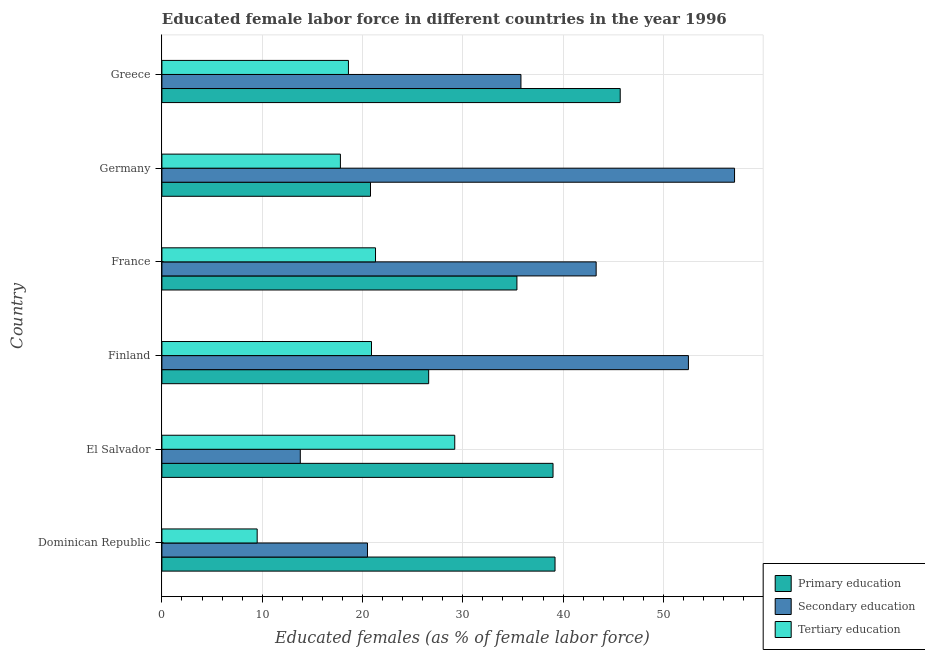How many different coloured bars are there?
Your response must be concise. 3. How many groups of bars are there?
Make the answer very short. 6. Are the number of bars per tick equal to the number of legend labels?
Make the answer very short. Yes. In how many cases, is the number of bars for a given country not equal to the number of legend labels?
Offer a very short reply. 0. What is the percentage of female labor force who received primary education in Germany?
Provide a succinct answer. 20.8. Across all countries, what is the maximum percentage of female labor force who received tertiary education?
Provide a short and direct response. 29.2. Across all countries, what is the minimum percentage of female labor force who received tertiary education?
Give a very brief answer. 9.5. In which country was the percentage of female labor force who received tertiary education maximum?
Your answer should be very brief. El Salvador. In which country was the percentage of female labor force who received secondary education minimum?
Make the answer very short. El Salvador. What is the total percentage of female labor force who received tertiary education in the graph?
Offer a very short reply. 117.3. What is the difference between the percentage of female labor force who received primary education in Greece and the percentage of female labor force who received tertiary education in France?
Keep it short and to the point. 24.4. What is the average percentage of female labor force who received secondary education per country?
Your answer should be very brief. 37.17. What is the difference between the percentage of female labor force who received primary education and percentage of female labor force who received tertiary education in Greece?
Provide a succinct answer. 27.1. In how many countries, is the percentage of female labor force who received tertiary education greater than 42 %?
Make the answer very short. 0. What is the ratio of the percentage of female labor force who received secondary education in Finland to that in Greece?
Provide a succinct answer. 1.47. Is the difference between the percentage of female labor force who received secondary education in Finland and Greece greater than the difference between the percentage of female labor force who received primary education in Finland and Greece?
Give a very brief answer. Yes. What is the difference between the highest and the second highest percentage of female labor force who received tertiary education?
Keep it short and to the point. 7.9. What is the difference between the highest and the lowest percentage of female labor force who received secondary education?
Make the answer very short. 43.3. What does the 1st bar from the top in Dominican Republic represents?
Give a very brief answer. Tertiary education. What does the 3rd bar from the bottom in Germany represents?
Make the answer very short. Tertiary education. Are the values on the major ticks of X-axis written in scientific E-notation?
Give a very brief answer. No. Does the graph contain grids?
Your response must be concise. Yes. How many legend labels are there?
Make the answer very short. 3. How are the legend labels stacked?
Ensure brevity in your answer.  Vertical. What is the title of the graph?
Give a very brief answer. Educated female labor force in different countries in the year 1996. Does "Spain" appear as one of the legend labels in the graph?
Provide a succinct answer. No. What is the label or title of the X-axis?
Make the answer very short. Educated females (as % of female labor force). What is the label or title of the Y-axis?
Offer a very short reply. Country. What is the Educated females (as % of female labor force) in Primary education in Dominican Republic?
Your answer should be compact. 39.2. What is the Educated females (as % of female labor force) in Primary education in El Salvador?
Provide a short and direct response. 39. What is the Educated females (as % of female labor force) of Secondary education in El Salvador?
Keep it short and to the point. 13.8. What is the Educated females (as % of female labor force) of Tertiary education in El Salvador?
Provide a succinct answer. 29.2. What is the Educated females (as % of female labor force) in Primary education in Finland?
Keep it short and to the point. 26.6. What is the Educated females (as % of female labor force) in Secondary education in Finland?
Offer a very short reply. 52.5. What is the Educated females (as % of female labor force) of Tertiary education in Finland?
Provide a short and direct response. 20.9. What is the Educated females (as % of female labor force) in Primary education in France?
Your answer should be very brief. 35.4. What is the Educated females (as % of female labor force) of Secondary education in France?
Provide a short and direct response. 43.3. What is the Educated females (as % of female labor force) in Tertiary education in France?
Keep it short and to the point. 21.3. What is the Educated females (as % of female labor force) in Primary education in Germany?
Ensure brevity in your answer.  20.8. What is the Educated females (as % of female labor force) in Secondary education in Germany?
Offer a very short reply. 57.1. What is the Educated females (as % of female labor force) in Tertiary education in Germany?
Your answer should be compact. 17.8. What is the Educated females (as % of female labor force) of Primary education in Greece?
Keep it short and to the point. 45.7. What is the Educated females (as % of female labor force) in Secondary education in Greece?
Ensure brevity in your answer.  35.8. What is the Educated females (as % of female labor force) in Tertiary education in Greece?
Your response must be concise. 18.6. Across all countries, what is the maximum Educated females (as % of female labor force) in Primary education?
Your answer should be very brief. 45.7. Across all countries, what is the maximum Educated females (as % of female labor force) in Secondary education?
Give a very brief answer. 57.1. Across all countries, what is the maximum Educated females (as % of female labor force) of Tertiary education?
Offer a very short reply. 29.2. Across all countries, what is the minimum Educated females (as % of female labor force) of Primary education?
Give a very brief answer. 20.8. Across all countries, what is the minimum Educated females (as % of female labor force) in Secondary education?
Offer a very short reply. 13.8. Across all countries, what is the minimum Educated females (as % of female labor force) of Tertiary education?
Offer a terse response. 9.5. What is the total Educated females (as % of female labor force) in Primary education in the graph?
Your answer should be very brief. 206.7. What is the total Educated females (as % of female labor force) in Secondary education in the graph?
Your response must be concise. 223. What is the total Educated females (as % of female labor force) of Tertiary education in the graph?
Your answer should be very brief. 117.3. What is the difference between the Educated females (as % of female labor force) of Primary education in Dominican Republic and that in El Salvador?
Ensure brevity in your answer.  0.2. What is the difference between the Educated females (as % of female labor force) of Tertiary education in Dominican Republic and that in El Salvador?
Provide a succinct answer. -19.7. What is the difference between the Educated females (as % of female labor force) of Secondary education in Dominican Republic and that in Finland?
Give a very brief answer. -32. What is the difference between the Educated females (as % of female labor force) of Tertiary education in Dominican Republic and that in Finland?
Your answer should be compact. -11.4. What is the difference between the Educated females (as % of female labor force) in Secondary education in Dominican Republic and that in France?
Give a very brief answer. -22.8. What is the difference between the Educated females (as % of female labor force) in Tertiary education in Dominican Republic and that in France?
Offer a very short reply. -11.8. What is the difference between the Educated females (as % of female labor force) in Primary education in Dominican Republic and that in Germany?
Offer a terse response. 18.4. What is the difference between the Educated females (as % of female labor force) in Secondary education in Dominican Republic and that in Germany?
Your answer should be very brief. -36.6. What is the difference between the Educated females (as % of female labor force) in Secondary education in Dominican Republic and that in Greece?
Offer a very short reply. -15.3. What is the difference between the Educated females (as % of female labor force) of Secondary education in El Salvador and that in Finland?
Your response must be concise. -38.7. What is the difference between the Educated females (as % of female labor force) in Tertiary education in El Salvador and that in Finland?
Your answer should be compact. 8.3. What is the difference between the Educated females (as % of female labor force) of Secondary education in El Salvador and that in France?
Keep it short and to the point. -29.5. What is the difference between the Educated females (as % of female labor force) of Tertiary education in El Salvador and that in France?
Provide a short and direct response. 7.9. What is the difference between the Educated females (as % of female labor force) in Primary education in El Salvador and that in Germany?
Your answer should be compact. 18.2. What is the difference between the Educated females (as % of female labor force) in Secondary education in El Salvador and that in Germany?
Give a very brief answer. -43.3. What is the difference between the Educated females (as % of female labor force) in Primary education in El Salvador and that in Greece?
Offer a terse response. -6.7. What is the difference between the Educated females (as % of female labor force) in Secondary education in El Salvador and that in Greece?
Offer a terse response. -22. What is the difference between the Educated females (as % of female labor force) of Primary education in Finland and that in France?
Your answer should be compact. -8.8. What is the difference between the Educated females (as % of female labor force) in Secondary education in Finland and that in France?
Give a very brief answer. 9.2. What is the difference between the Educated females (as % of female labor force) in Tertiary education in Finland and that in France?
Your answer should be very brief. -0.4. What is the difference between the Educated females (as % of female labor force) in Tertiary education in Finland and that in Germany?
Offer a terse response. 3.1. What is the difference between the Educated females (as % of female labor force) in Primary education in Finland and that in Greece?
Provide a succinct answer. -19.1. What is the difference between the Educated females (as % of female labor force) in Tertiary education in Finland and that in Greece?
Keep it short and to the point. 2.3. What is the difference between the Educated females (as % of female labor force) of Secondary education in France and that in Germany?
Keep it short and to the point. -13.8. What is the difference between the Educated females (as % of female labor force) of Tertiary education in France and that in Germany?
Offer a terse response. 3.5. What is the difference between the Educated females (as % of female labor force) of Primary education in France and that in Greece?
Keep it short and to the point. -10.3. What is the difference between the Educated females (as % of female labor force) of Tertiary education in France and that in Greece?
Provide a succinct answer. 2.7. What is the difference between the Educated females (as % of female labor force) of Primary education in Germany and that in Greece?
Your answer should be compact. -24.9. What is the difference between the Educated females (as % of female labor force) in Secondary education in Germany and that in Greece?
Provide a short and direct response. 21.3. What is the difference between the Educated females (as % of female labor force) of Tertiary education in Germany and that in Greece?
Offer a terse response. -0.8. What is the difference between the Educated females (as % of female labor force) of Primary education in Dominican Republic and the Educated females (as % of female labor force) of Secondary education in El Salvador?
Ensure brevity in your answer.  25.4. What is the difference between the Educated females (as % of female labor force) in Primary education in Dominican Republic and the Educated females (as % of female labor force) in Secondary education in Finland?
Offer a terse response. -13.3. What is the difference between the Educated females (as % of female labor force) in Primary education in Dominican Republic and the Educated females (as % of female labor force) in Tertiary education in Finland?
Your response must be concise. 18.3. What is the difference between the Educated females (as % of female labor force) of Primary education in Dominican Republic and the Educated females (as % of female labor force) of Secondary education in Germany?
Offer a terse response. -17.9. What is the difference between the Educated females (as % of female labor force) of Primary education in Dominican Republic and the Educated females (as % of female labor force) of Tertiary education in Germany?
Your answer should be compact. 21.4. What is the difference between the Educated females (as % of female labor force) in Primary education in Dominican Republic and the Educated females (as % of female labor force) in Tertiary education in Greece?
Give a very brief answer. 20.6. What is the difference between the Educated females (as % of female labor force) in Secondary education in Dominican Republic and the Educated females (as % of female labor force) in Tertiary education in Greece?
Keep it short and to the point. 1.9. What is the difference between the Educated females (as % of female labor force) of Primary education in El Salvador and the Educated females (as % of female labor force) of Secondary education in Finland?
Your answer should be compact. -13.5. What is the difference between the Educated females (as % of female labor force) in Primary education in El Salvador and the Educated females (as % of female labor force) in Tertiary education in Finland?
Provide a succinct answer. 18.1. What is the difference between the Educated females (as % of female labor force) of Primary education in El Salvador and the Educated females (as % of female labor force) of Secondary education in France?
Offer a terse response. -4.3. What is the difference between the Educated females (as % of female labor force) of Primary education in El Salvador and the Educated females (as % of female labor force) of Tertiary education in France?
Ensure brevity in your answer.  17.7. What is the difference between the Educated females (as % of female labor force) of Secondary education in El Salvador and the Educated females (as % of female labor force) of Tertiary education in France?
Keep it short and to the point. -7.5. What is the difference between the Educated females (as % of female labor force) in Primary education in El Salvador and the Educated females (as % of female labor force) in Secondary education in Germany?
Your answer should be very brief. -18.1. What is the difference between the Educated females (as % of female labor force) of Primary education in El Salvador and the Educated females (as % of female labor force) of Tertiary education in Germany?
Make the answer very short. 21.2. What is the difference between the Educated females (as % of female labor force) of Primary education in El Salvador and the Educated females (as % of female labor force) of Tertiary education in Greece?
Your answer should be very brief. 20.4. What is the difference between the Educated females (as % of female labor force) of Primary education in Finland and the Educated females (as % of female labor force) of Secondary education in France?
Offer a very short reply. -16.7. What is the difference between the Educated females (as % of female labor force) of Secondary education in Finland and the Educated females (as % of female labor force) of Tertiary education in France?
Ensure brevity in your answer.  31.2. What is the difference between the Educated females (as % of female labor force) of Primary education in Finland and the Educated females (as % of female labor force) of Secondary education in Germany?
Your answer should be compact. -30.5. What is the difference between the Educated females (as % of female labor force) in Primary education in Finland and the Educated females (as % of female labor force) in Tertiary education in Germany?
Provide a succinct answer. 8.8. What is the difference between the Educated females (as % of female labor force) in Secondary education in Finland and the Educated females (as % of female labor force) in Tertiary education in Germany?
Your answer should be very brief. 34.7. What is the difference between the Educated females (as % of female labor force) in Primary education in Finland and the Educated females (as % of female labor force) in Tertiary education in Greece?
Offer a very short reply. 8. What is the difference between the Educated females (as % of female labor force) of Secondary education in Finland and the Educated females (as % of female labor force) of Tertiary education in Greece?
Provide a succinct answer. 33.9. What is the difference between the Educated females (as % of female labor force) in Primary education in France and the Educated females (as % of female labor force) in Secondary education in Germany?
Keep it short and to the point. -21.7. What is the difference between the Educated females (as % of female labor force) of Primary education in France and the Educated females (as % of female labor force) of Tertiary education in Greece?
Provide a short and direct response. 16.8. What is the difference between the Educated females (as % of female labor force) of Secondary education in France and the Educated females (as % of female labor force) of Tertiary education in Greece?
Provide a short and direct response. 24.7. What is the difference between the Educated females (as % of female labor force) of Primary education in Germany and the Educated females (as % of female labor force) of Secondary education in Greece?
Give a very brief answer. -15. What is the difference between the Educated females (as % of female labor force) in Secondary education in Germany and the Educated females (as % of female labor force) in Tertiary education in Greece?
Make the answer very short. 38.5. What is the average Educated females (as % of female labor force) of Primary education per country?
Offer a very short reply. 34.45. What is the average Educated females (as % of female labor force) of Secondary education per country?
Your response must be concise. 37.17. What is the average Educated females (as % of female labor force) of Tertiary education per country?
Make the answer very short. 19.55. What is the difference between the Educated females (as % of female labor force) in Primary education and Educated females (as % of female labor force) in Secondary education in Dominican Republic?
Your answer should be very brief. 18.7. What is the difference between the Educated females (as % of female labor force) in Primary education and Educated females (as % of female labor force) in Tertiary education in Dominican Republic?
Ensure brevity in your answer.  29.7. What is the difference between the Educated females (as % of female labor force) in Primary education and Educated females (as % of female labor force) in Secondary education in El Salvador?
Give a very brief answer. 25.2. What is the difference between the Educated females (as % of female labor force) in Secondary education and Educated females (as % of female labor force) in Tertiary education in El Salvador?
Provide a short and direct response. -15.4. What is the difference between the Educated females (as % of female labor force) in Primary education and Educated females (as % of female labor force) in Secondary education in Finland?
Make the answer very short. -25.9. What is the difference between the Educated females (as % of female labor force) of Secondary education and Educated females (as % of female labor force) of Tertiary education in Finland?
Provide a short and direct response. 31.6. What is the difference between the Educated females (as % of female labor force) in Primary education and Educated females (as % of female labor force) in Tertiary education in France?
Your response must be concise. 14.1. What is the difference between the Educated females (as % of female labor force) in Primary education and Educated females (as % of female labor force) in Secondary education in Germany?
Make the answer very short. -36.3. What is the difference between the Educated females (as % of female labor force) of Secondary education and Educated females (as % of female labor force) of Tertiary education in Germany?
Your answer should be compact. 39.3. What is the difference between the Educated females (as % of female labor force) of Primary education and Educated females (as % of female labor force) of Tertiary education in Greece?
Your answer should be compact. 27.1. What is the ratio of the Educated females (as % of female labor force) of Primary education in Dominican Republic to that in El Salvador?
Keep it short and to the point. 1.01. What is the ratio of the Educated females (as % of female labor force) in Secondary education in Dominican Republic to that in El Salvador?
Offer a terse response. 1.49. What is the ratio of the Educated females (as % of female labor force) in Tertiary education in Dominican Republic to that in El Salvador?
Give a very brief answer. 0.33. What is the ratio of the Educated females (as % of female labor force) in Primary education in Dominican Republic to that in Finland?
Give a very brief answer. 1.47. What is the ratio of the Educated females (as % of female labor force) of Secondary education in Dominican Republic to that in Finland?
Keep it short and to the point. 0.39. What is the ratio of the Educated females (as % of female labor force) in Tertiary education in Dominican Republic to that in Finland?
Your answer should be very brief. 0.45. What is the ratio of the Educated females (as % of female labor force) of Primary education in Dominican Republic to that in France?
Make the answer very short. 1.11. What is the ratio of the Educated females (as % of female labor force) in Secondary education in Dominican Republic to that in France?
Offer a very short reply. 0.47. What is the ratio of the Educated females (as % of female labor force) in Tertiary education in Dominican Republic to that in France?
Keep it short and to the point. 0.45. What is the ratio of the Educated females (as % of female labor force) in Primary education in Dominican Republic to that in Germany?
Give a very brief answer. 1.88. What is the ratio of the Educated females (as % of female labor force) of Secondary education in Dominican Republic to that in Germany?
Provide a short and direct response. 0.36. What is the ratio of the Educated females (as % of female labor force) of Tertiary education in Dominican Republic to that in Germany?
Provide a succinct answer. 0.53. What is the ratio of the Educated females (as % of female labor force) in Primary education in Dominican Republic to that in Greece?
Ensure brevity in your answer.  0.86. What is the ratio of the Educated females (as % of female labor force) in Secondary education in Dominican Republic to that in Greece?
Offer a very short reply. 0.57. What is the ratio of the Educated females (as % of female labor force) of Tertiary education in Dominican Republic to that in Greece?
Provide a short and direct response. 0.51. What is the ratio of the Educated females (as % of female labor force) in Primary education in El Salvador to that in Finland?
Keep it short and to the point. 1.47. What is the ratio of the Educated females (as % of female labor force) in Secondary education in El Salvador to that in Finland?
Ensure brevity in your answer.  0.26. What is the ratio of the Educated females (as % of female labor force) in Tertiary education in El Salvador to that in Finland?
Offer a terse response. 1.4. What is the ratio of the Educated females (as % of female labor force) of Primary education in El Salvador to that in France?
Your response must be concise. 1.1. What is the ratio of the Educated females (as % of female labor force) in Secondary education in El Salvador to that in France?
Your answer should be very brief. 0.32. What is the ratio of the Educated females (as % of female labor force) in Tertiary education in El Salvador to that in France?
Your answer should be compact. 1.37. What is the ratio of the Educated females (as % of female labor force) of Primary education in El Salvador to that in Germany?
Offer a terse response. 1.88. What is the ratio of the Educated females (as % of female labor force) in Secondary education in El Salvador to that in Germany?
Offer a terse response. 0.24. What is the ratio of the Educated females (as % of female labor force) of Tertiary education in El Salvador to that in Germany?
Your answer should be compact. 1.64. What is the ratio of the Educated females (as % of female labor force) in Primary education in El Salvador to that in Greece?
Make the answer very short. 0.85. What is the ratio of the Educated females (as % of female labor force) of Secondary education in El Salvador to that in Greece?
Provide a short and direct response. 0.39. What is the ratio of the Educated females (as % of female labor force) of Tertiary education in El Salvador to that in Greece?
Ensure brevity in your answer.  1.57. What is the ratio of the Educated females (as % of female labor force) in Primary education in Finland to that in France?
Offer a terse response. 0.75. What is the ratio of the Educated females (as % of female labor force) of Secondary education in Finland to that in France?
Your answer should be compact. 1.21. What is the ratio of the Educated females (as % of female labor force) of Tertiary education in Finland to that in France?
Offer a very short reply. 0.98. What is the ratio of the Educated females (as % of female labor force) of Primary education in Finland to that in Germany?
Your response must be concise. 1.28. What is the ratio of the Educated females (as % of female labor force) in Secondary education in Finland to that in Germany?
Ensure brevity in your answer.  0.92. What is the ratio of the Educated females (as % of female labor force) of Tertiary education in Finland to that in Germany?
Your answer should be compact. 1.17. What is the ratio of the Educated females (as % of female labor force) of Primary education in Finland to that in Greece?
Give a very brief answer. 0.58. What is the ratio of the Educated females (as % of female labor force) of Secondary education in Finland to that in Greece?
Your answer should be compact. 1.47. What is the ratio of the Educated females (as % of female labor force) of Tertiary education in Finland to that in Greece?
Provide a succinct answer. 1.12. What is the ratio of the Educated females (as % of female labor force) in Primary education in France to that in Germany?
Provide a succinct answer. 1.7. What is the ratio of the Educated females (as % of female labor force) of Secondary education in France to that in Germany?
Offer a very short reply. 0.76. What is the ratio of the Educated females (as % of female labor force) in Tertiary education in France to that in Germany?
Your response must be concise. 1.2. What is the ratio of the Educated females (as % of female labor force) of Primary education in France to that in Greece?
Your answer should be very brief. 0.77. What is the ratio of the Educated females (as % of female labor force) of Secondary education in France to that in Greece?
Provide a short and direct response. 1.21. What is the ratio of the Educated females (as % of female labor force) in Tertiary education in France to that in Greece?
Give a very brief answer. 1.15. What is the ratio of the Educated females (as % of female labor force) in Primary education in Germany to that in Greece?
Your answer should be very brief. 0.46. What is the ratio of the Educated females (as % of female labor force) of Secondary education in Germany to that in Greece?
Offer a very short reply. 1.59. What is the difference between the highest and the second highest Educated females (as % of female labor force) in Secondary education?
Offer a terse response. 4.6. What is the difference between the highest and the lowest Educated females (as % of female labor force) of Primary education?
Give a very brief answer. 24.9. What is the difference between the highest and the lowest Educated females (as % of female labor force) in Secondary education?
Provide a short and direct response. 43.3. 